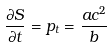<formula> <loc_0><loc_0><loc_500><loc_500>\frac { \partial S } { \partial t } = p _ { t } = \frac { a c ^ { 2 } } { b }</formula> 